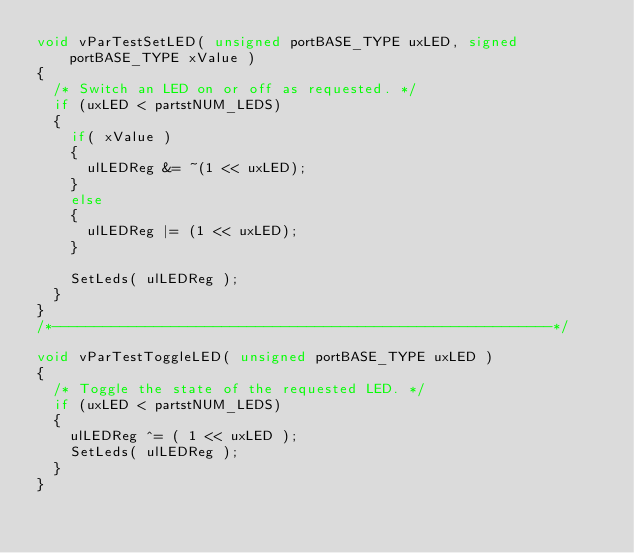<code> <loc_0><loc_0><loc_500><loc_500><_C_>void vParTestSetLED( unsigned portBASE_TYPE uxLED, signed portBASE_TYPE xValue )
{
	/* Switch an LED on or off as requested. */
	if (uxLED < partstNUM_LEDS)
	{
		if( xValue )
		{
			ulLEDReg &= ~(1 << uxLED);
		}
		else
		{
			ulLEDReg |= (1 << uxLED);
		}

		SetLeds( ulLEDReg );
	}
}
/*-----------------------------------------------------------*/

void vParTestToggleLED( unsigned portBASE_TYPE uxLED )
{
	/* Toggle the state of the requested LED. */
	if (uxLED < partstNUM_LEDS)
	{
		ulLEDReg ^= ( 1 << uxLED );
		SetLeds( ulLEDReg );
	}
}

</code> 